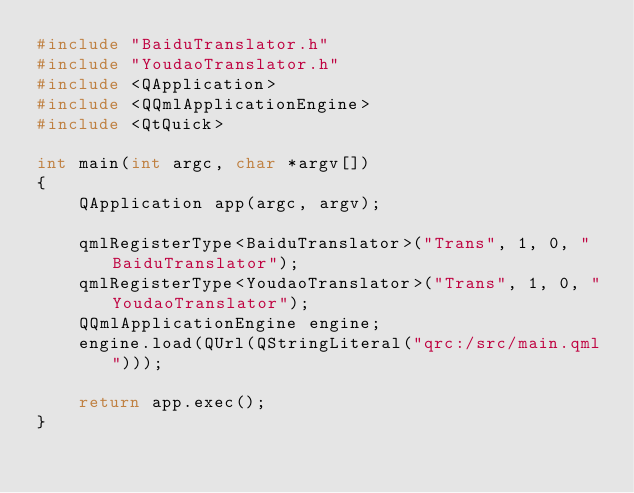<code> <loc_0><loc_0><loc_500><loc_500><_C++_>#include "BaiduTranslator.h"
#include "YoudaoTranslator.h"
#include <QApplication>
#include <QQmlApplicationEngine>
#include <QtQuick>

int main(int argc, char *argv[])
{
    QApplication app(argc, argv);

    qmlRegisterType<BaiduTranslator>("Trans", 1, 0, "BaiduTranslator");
    qmlRegisterType<YoudaoTranslator>("Trans", 1, 0, "YoudaoTranslator");
    QQmlApplicationEngine engine;
    engine.load(QUrl(QStringLiteral("qrc:/src/main.qml")));

    return app.exec();
}
</code> 